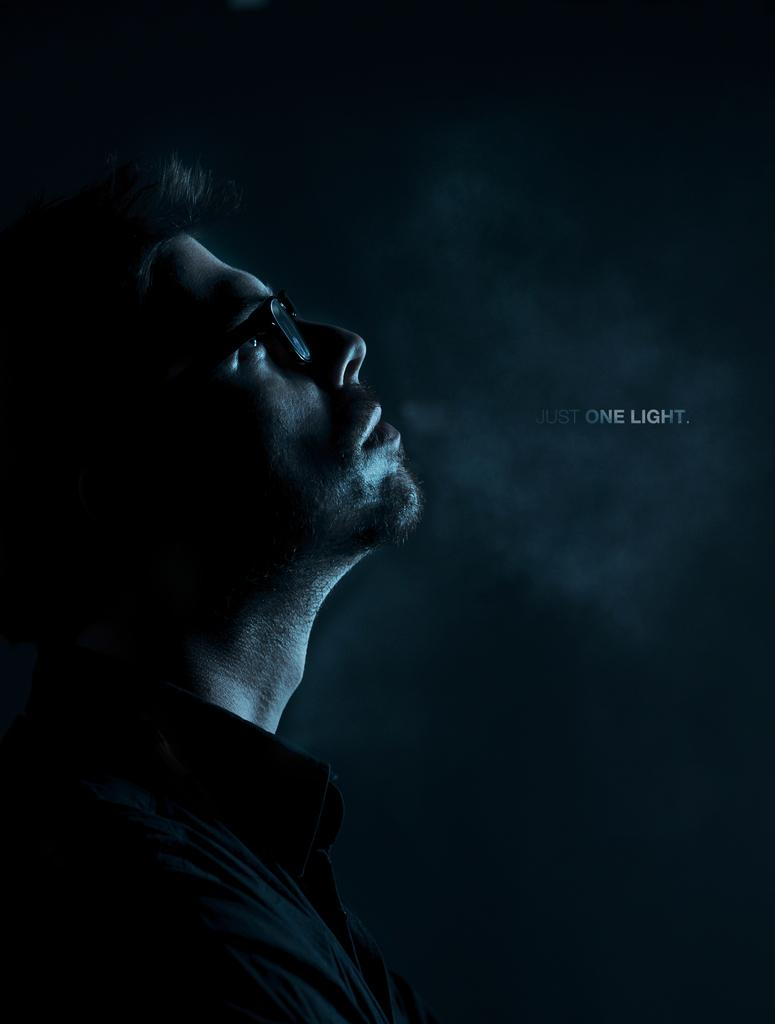Who is the main subject in the image? There is a man in the image. Where is the man located in the image? The man is in the front of the image. What accessory is the man wearing? The man is wearing spectacles. What can be seen on the right side of the image? There is text on the right side of the image. How would you describe the background of the image? The background of the image is dark. What type of jeans is the man wearing in the image? The provided facts do not mention any jeans being worn by the man in the image. --- Facts: 1. There is a car in the image. 2. The car is red. 3. The car has four wheels. 4. There are people in the car. 5. The car is parked on the street. Absurd Topics: parrot, ocean, dance Conversation: What is the main subject in the image? There is a car in the image. What color is the car? The car is red. How many wheels does the car have? The car has four wheels. Are there any passengers in the car? Yes, there are people in the car. Where is the car located in the image? The car is parked on the street. Reasoning: Let's think step by step in order to produce the conversation. We start by identifying the main subject in the image, which is the car. Then, we describe its color, number of wheels, and the presence of passengers. Finally, we mention the car's location to give a sense of the overall image's context. Absurd Question/Answer: Can you see a parrot flying over the ocean in the image? There is no parrot or ocean present in the image; it features a red car parked on the street. 